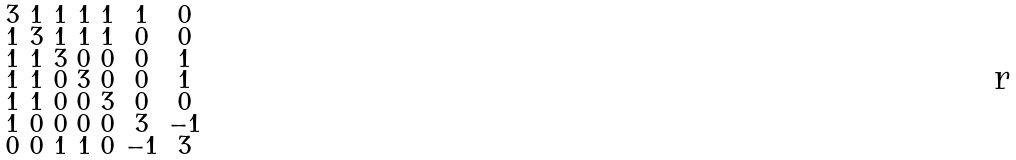Convert formula to latex. <formula><loc_0><loc_0><loc_500><loc_500>\begin{smallmatrix} 3 & 1 & 1 & 1 & 1 & 1 & 0 \\ 1 & 3 & 1 & 1 & 1 & 0 & 0 \\ 1 & 1 & 3 & 0 & 0 & 0 & 1 \\ 1 & 1 & 0 & 3 & 0 & 0 & 1 \\ 1 & 1 & 0 & 0 & 3 & 0 & 0 \\ 1 & 0 & 0 & 0 & 0 & 3 & - 1 \\ 0 & 0 & 1 & 1 & 0 & - 1 & 3 \end{smallmatrix}</formula> 